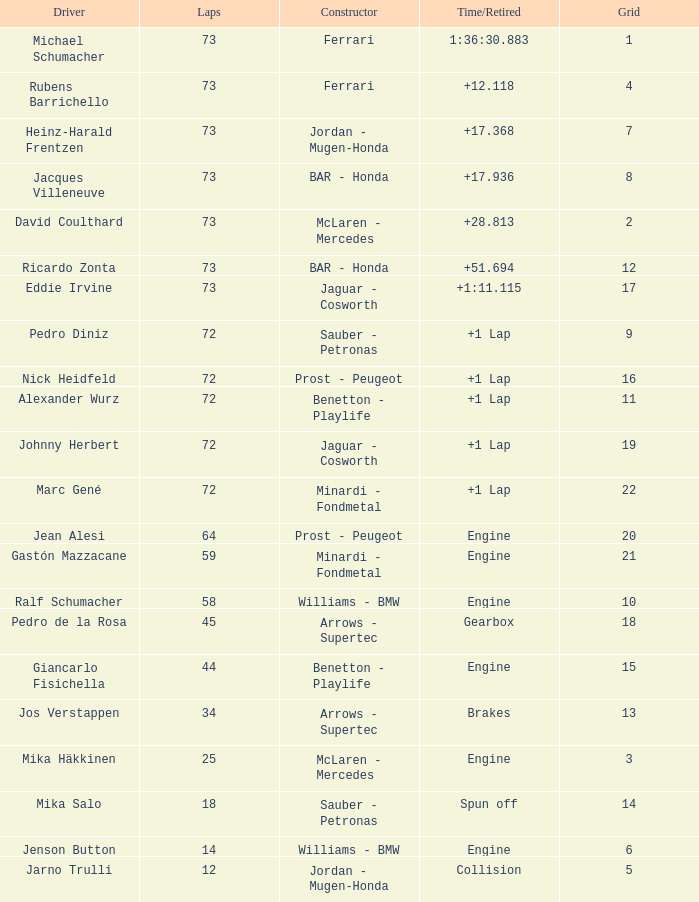Parse the table in full. {'header': ['Driver', 'Laps', 'Constructor', 'Time/Retired', 'Grid'], 'rows': [['Michael Schumacher', '73', 'Ferrari', '1:36:30.883', '1'], ['Rubens Barrichello', '73', 'Ferrari', '+12.118', '4'], ['Heinz-Harald Frentzen', '73', 'Jordan - Mugen-Honda', '+17.368', '7'], ['Jacques Villeneuve', '73', 'BAR - Honda', '+17.936', '8'], ['David Coulthard', '73', 'McLaren - Mercedes', '+28.813', '2'], ['Ricardo Zonta', '73', 'BAR - Honda', '+51.694', '12'], ['Eddie Irvine', '73', 'Jaguar - Cosworth', '+1:11.115', '17'], ['Pedro Diniz', '72', 'Sauber - Petronas', '+1 Lap', '9'], ['Nick Heidfeld', '72', 'Prost - Peugeot', '+1 Lap', '16'], ['Alexander Wurz', '72', 'Benetton - Playlife', '+1 Lap', '11'], ['Johnny Herbert', '72', 'Jaguar - Cosworth', '+1 Lap', '19'], ['Marc Gené', '72', 'Minardi - Fondmetal', '+1 Lap', '22'], ['Jean Alesi', '64', 'Prost - Peugeot', 'Engine', '20'], ['Gastón Mazzacane', '59', 'Minardi - Fondmetal', 'Engine', '21'], ['Ralf Schumacher', '58', 'Williams - BMW', 'Engine', '10'], ['Pedro de la Rosa', '45', 'Arrows - Supertec', 'Gearbox', '18'], ['Giancarlo Fisichella', '44', 'Benetton - Playlife', 'Engine', '15'], ['Jos Verstappen', '34', 'Arrows - Supertec', 'Brakes', '13'], ['Mika Häkkinen', '25', 'McLaren - Mercedes', 'Engine', '3'], ['Mika Salo', '18', 'Sauber - Petronas', 'Spun off', '14'], ['Jenson Button', '14', 'Williams - BMW', 'Engine', '6'], ['Jarno Trulli', '12', 'Jordan - Mugen-Honda', 'Collision', '5']]} How many laps did Giancarlo Fisichella do with a grid larger than 15? 0.0. 